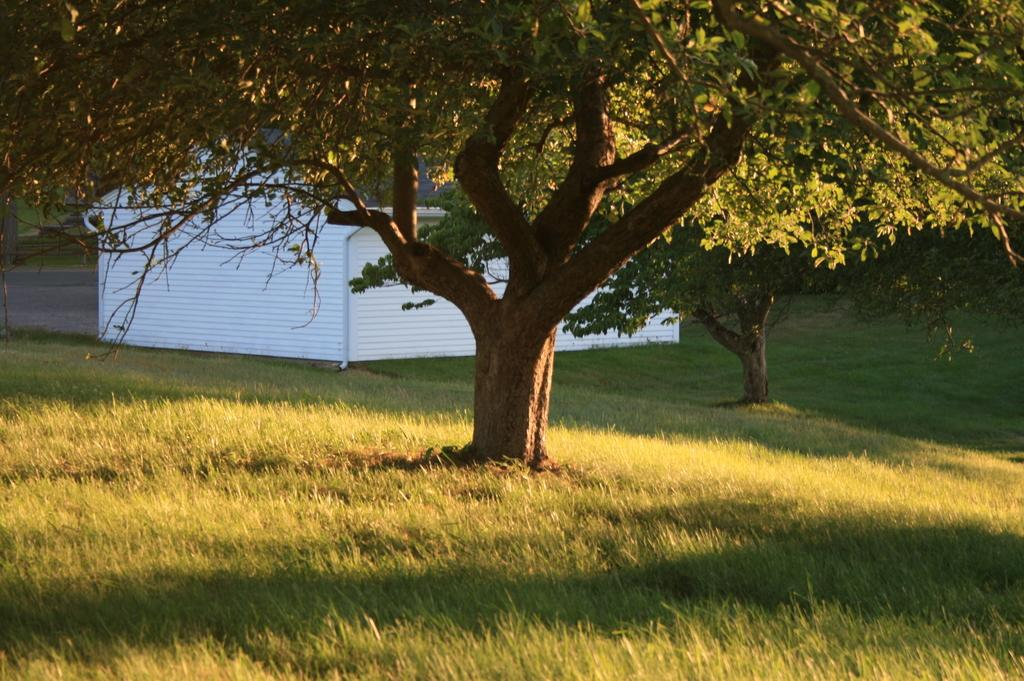What type of vegetation is present on the ground in the image? There is grass on the ground in the image. What other natural elements can be seen in the image? There are trees in the image. What type of structure is visible in the background of the image? There appears to be a house in the background of the image. How many cows are grazing in the grass in the image? There are no cows present in the image; it features grass and trees. What is the value of the house in the background of the image? The value of the house cannot be determined from the image, as it only provides a visual representation of the house and not its monetary worth. 